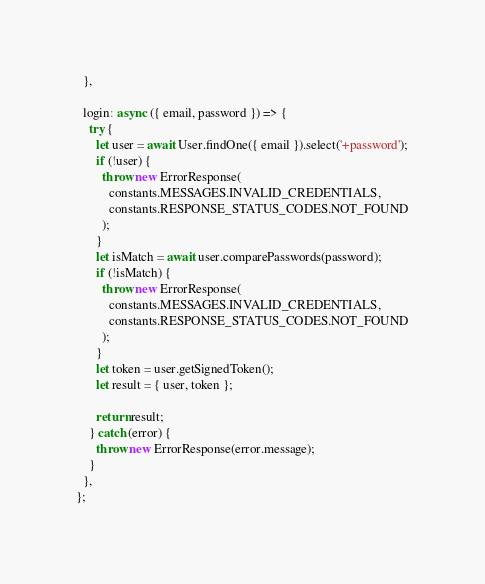Convert code to text. <code><loc_0><loc_0><loc_500><loc_500><_JavaScript_>  },

  login: async ({ email, password }) => {
    try {
      let user = await User.findOne({ email }).select('+password');
      if (!user) {
        throw new ErrorResponse(
          constants.MESSAGES.INVALID_CREDENTIALS,
          constants.RESPONSE_STATUS_CODES.NOT_FOUND
        );
      }
      let isMatch = await user.comparePasswords(password);
      if (!isMatch) {
        throw new ErrorResponse(
          constants.MESSAGES.INVALID_CREDENTIALS,
          constants.RESPONSE_STATUS_CODES.NOT_FOUND
        );
      }
      let token = user.getSignedToken();
      let result = { user, token };

      return result;
    } catch (error) {
      throw new ErrorResponse(error.message);
    }
  },
};
</code> 